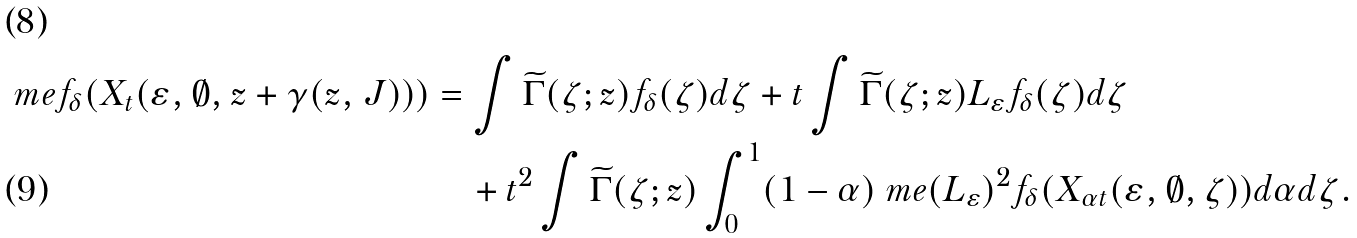Convert formula to latex. <formula><loc_0><loc_0><loc_500><loc_500>\ m e f _ { \delta } ( X _ { t } ( \varepsilon , \emptyset , z + \gamma ( z , J ) ) ) & = \int \widetilde { \Gamma } ( \zeta ; z ) f _ { \delta } ( \zeta ) d \zeta + t \int \widetilde { \Gamma } ( \zeta ; z ) L _ { \varepsilon } f _ { \delta } ( \zeta ) d \zeta \\ & \quad + t ^ { 2 } \int \widetilde { \Gamma } ( \zeta ; z ) \int _ { 0 } ^ { 1 } ( 1 - \alpha ) \ m e ( L _ { \varepsilon } ) ^ { 2 } f _ { \delta } ( X _ { \alpha t } ( \varepsilon , \emptyset , \zeta ) ) d \alpha d \zeta .</formula> 